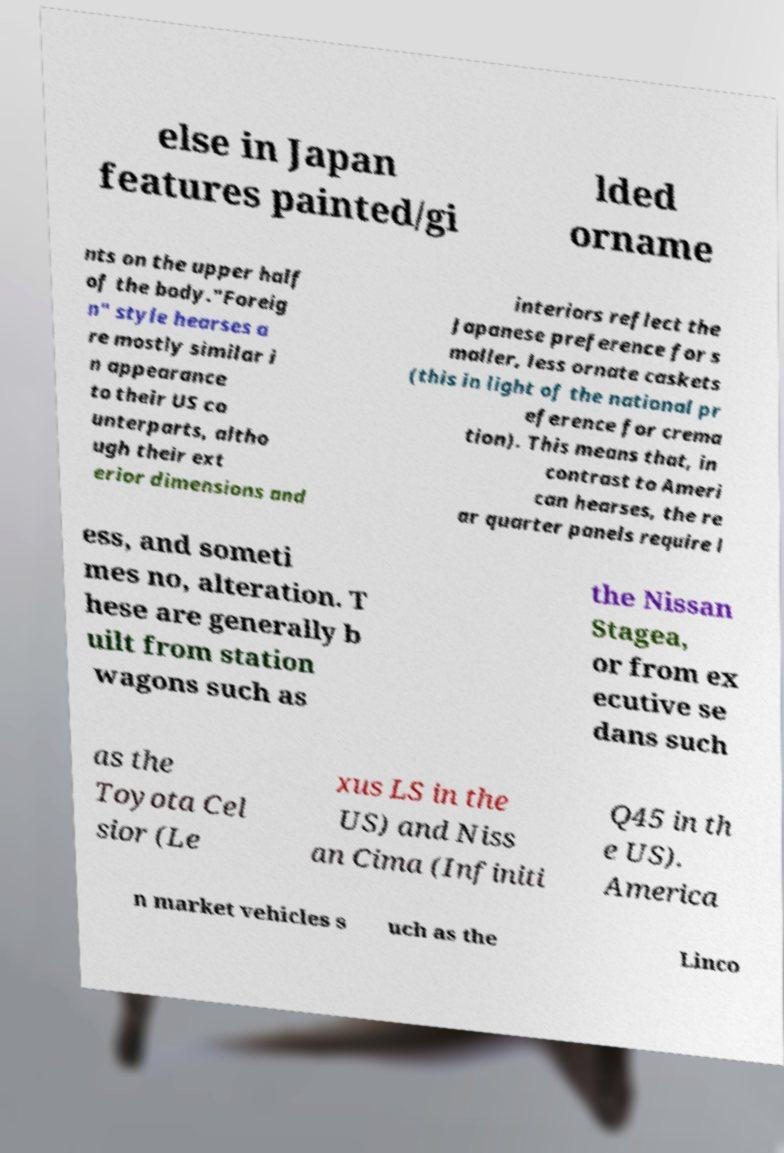Can you read and provide the text displayed in the image?This photo seems to have some interesting text. Can you extract and type it out for me? else in Japan features painted/gi lded orname nts on the upper half of the body."Foreig n" style hearses a re mostly similar i n appearance to their US co unterparts, altho ugh their ext erior dimensions and interiors reflect the Japanese preference for s maller, less ornate caskets (this in light of the national pr eference for crema tion). This means that, in contrast to Ameri can hearses, the re ar quarter panels require l ess, and someti mes no, alteration. T hese are generally b uilt from station wagons such as the Nissan Stagea, or from ex ecutive se dans such as the Toyota Cel sior (Le xus LS in the US) and Niss an Cima (Infiniti Q45 in th e US). America n market vehicles s uch as the Linco 